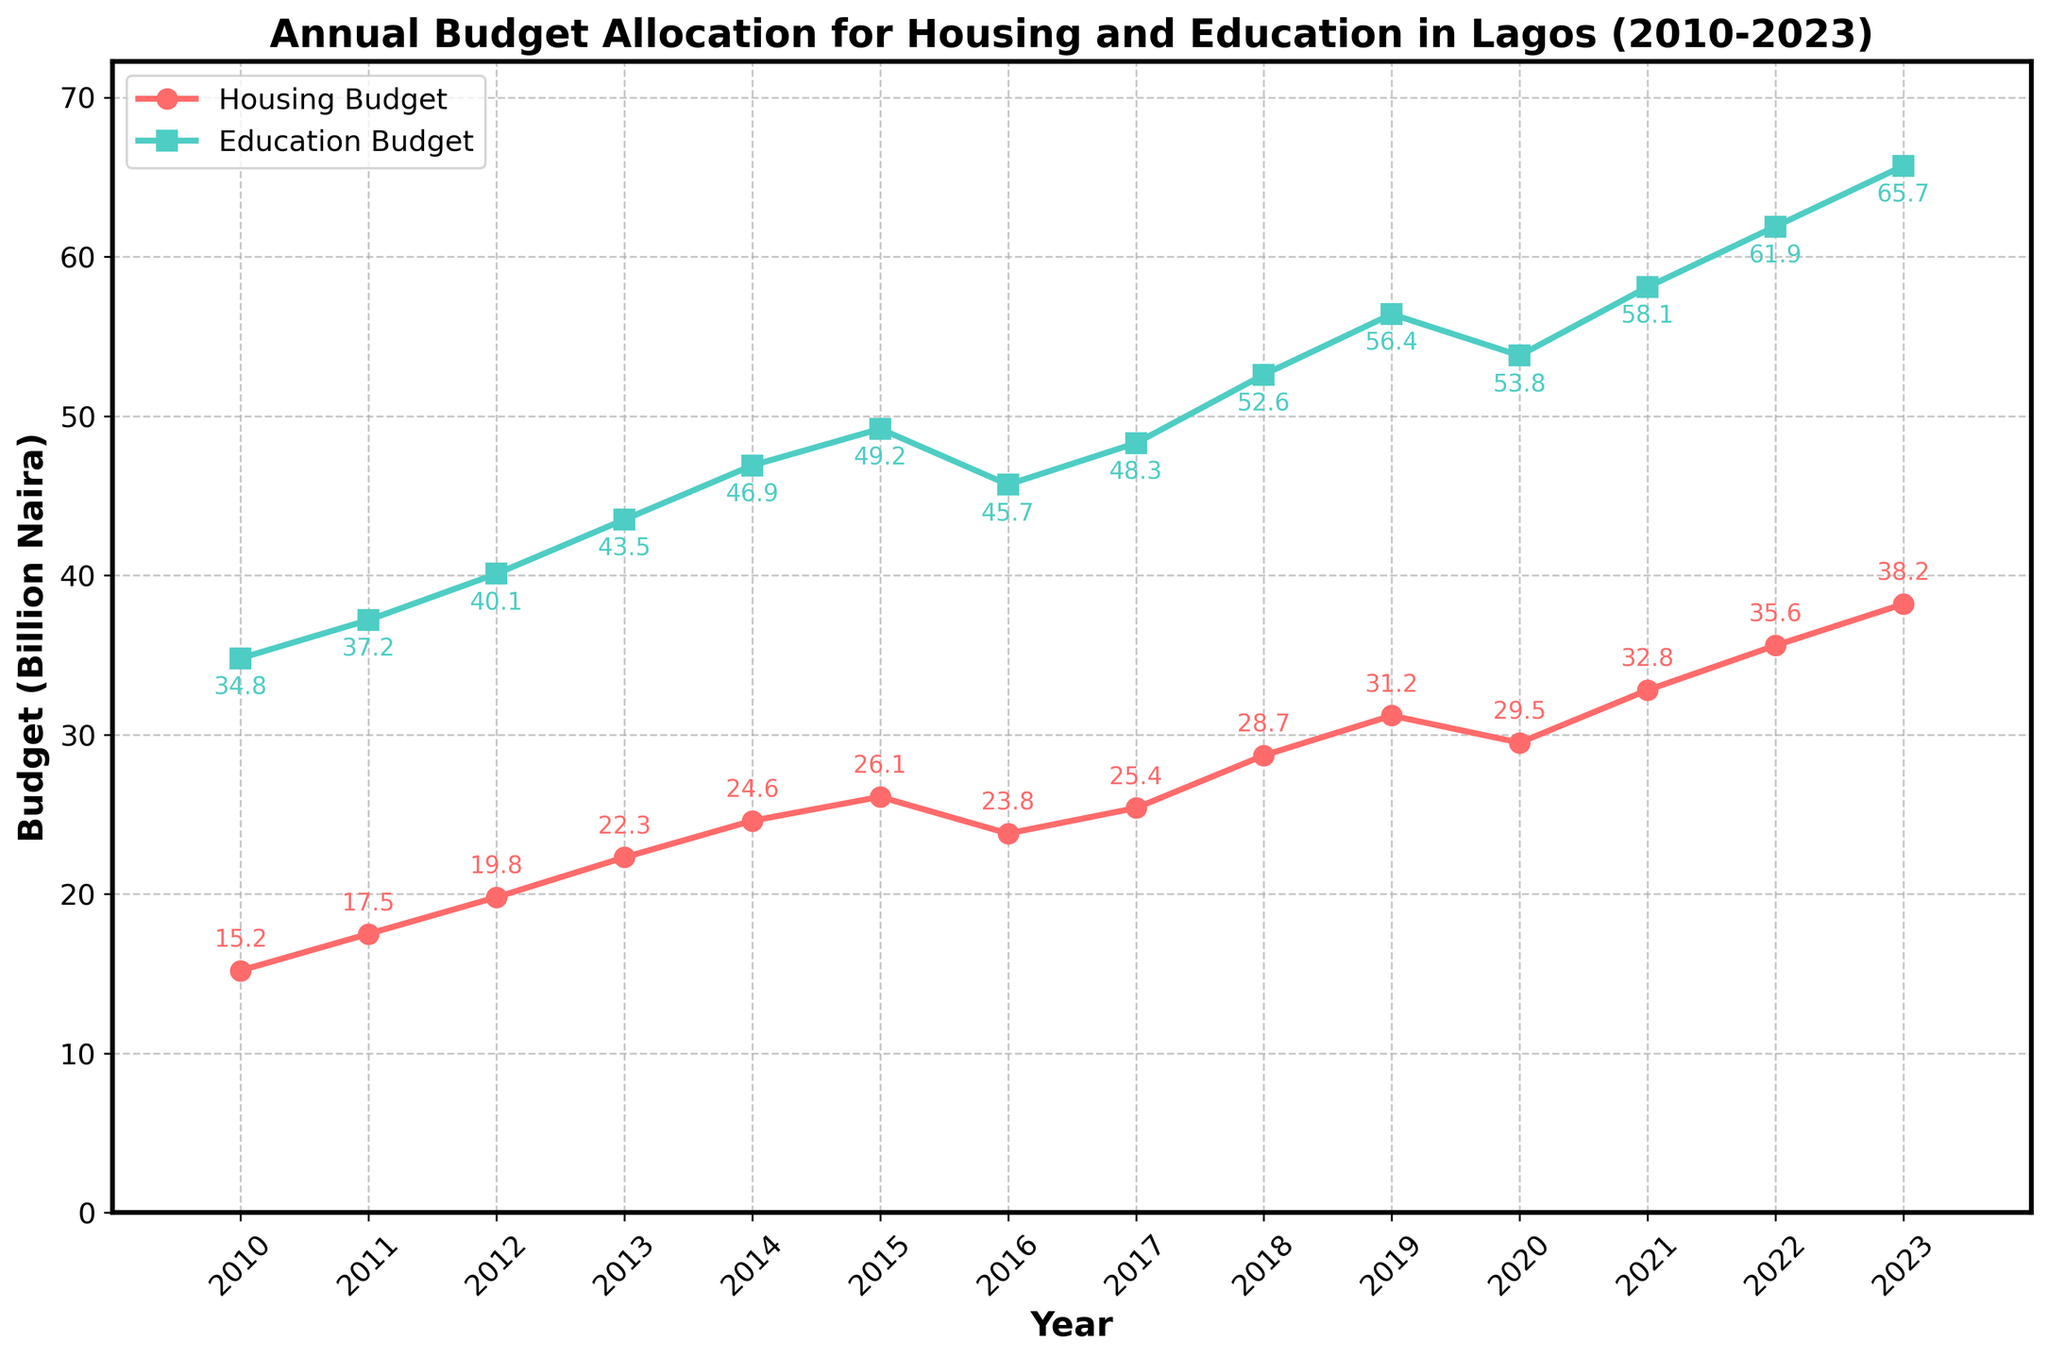What was the annual budget allocation for housing and education in Lagos in 2010? The annual budget allocation for housing in 2010 was represented by the point on the red line at 2010, and similarly for education on the green line at 2010. The housing budget was 15.2 billion Naira, and the education budget was 34.8 billion Naira.
Answer: Housing: 15.2 billion Naira, Education: 34.8 billion Naira How did the annual budget allocations for housing and education in 2020 compare? By looking at the points on the red and green lines at the year 2020, the housing budget was 29.5 billion Naira, and the education budget was 53.8 billion Naira. The education budget is greater than the housing budget.
Answer: Education: 53.8 billion Naira, Housing: 29.5 billion Naira By how much did the housing budget increase from 2010 to 2023? The housing budget in 2010 was 15.2 billion Naira, and in 2023 it was 38.2 billion Naira. The increase is calculated by subtracting the 2010 budget from the 2023 budget: 38.2 - 15.2 = 23.0 billion Naira.
Answer: 23.0 billion Naira What was the average annual budget for education over the period 2010-2023? To find the average, sum the education budgets from 2010 to 2023 and divide by the number of years (14 years). The calculations: (34.8 + 37.2 + 40.1 + 43.5 + 46.9 + 49.2 + 45.7 + 48.3 + 52.6 + 56.4 + 53.8 + 58.1 + 61.9 + 65.7) / 14 = 50.3 billion Naira (approx.)
Answer: 50.3 billion Naira (approx.) In which year did the housing budget experience the largest decrease compared to the previous year? Observing the red line, we see a decline between 2015 and 2016. The housing budget went from 26.1 billion Naira in 2015 to 23.8 billion Naira in 2016. The drop is calculated as 26.1 - 23.8 = 2.3 billion Naira, which is the largest decrease.
Answer: 2016 Between which consecutive years did the education budget see the largest increase? By comparing the green line heights year by year, the biggest jump is seen from 2021 to 2022, where it increased from 58.1 billion Naira to 61.9 billion Naira. The increase is 61.9 - 58.1 = 3.8 billion Naira.
Answer: Between 2021 and 2022 What is the ratio of the education budget to the housing budget in 2023? The education budget in 2023 is 65.7 billion Naira, and the housing budget is 38.2 billion Naira. The ratio is calculated by dividing the education budget by the housing budget: 65.7 / 38.2 ≈ 1.72.
Answer: Approximately 1.72 What trend do you observe in the annual budget allocation for housing from 2010 to 2023? Observing the red line, the housing budget generally increases most years from 2010 to 2023, with a notable decrease in 2016. Overall, there is an increasing trend.
Answer: Increasing trend with a dip in 2016 Which year had the closest budget values for housing and education, and what were those values? The closest values appear between the red and green points in 2016: Housing had 23.8 billion Naira, and Education had 45.7 billion Naira, which is still significantly different, questioning the overall comparison judgment.
Answer: 2016 - Housing: 23.8 billion Naira, Education: 45.7 billion Naira 